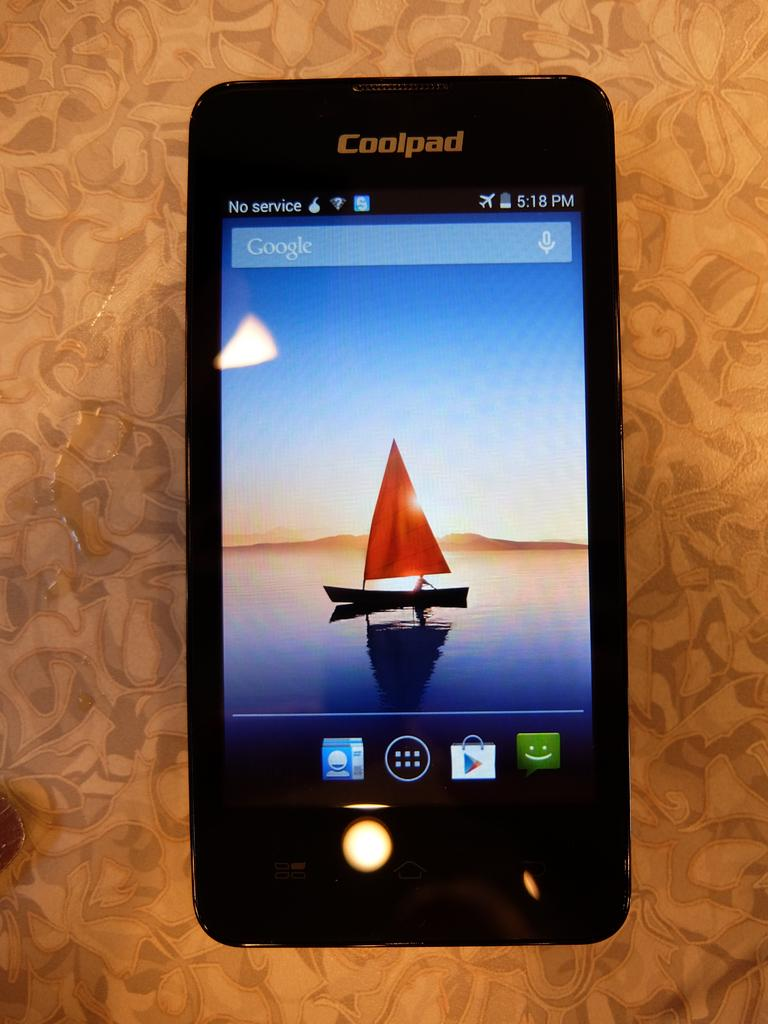<image>
Summarize the visual content of the image. A cellphone has the name Coolpad on its upper part, 